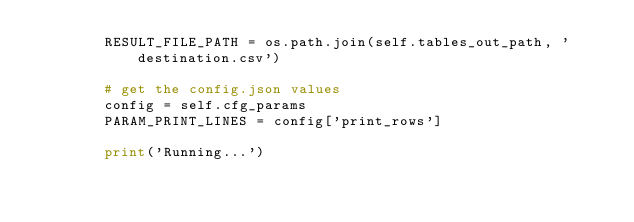<code> <loc_0><loc_0><loc_500><loc_500><_Python_>        RESULT_FILE_PATH = os.path.join(self.tables_out_path, 'destination.csv')

        # get the config.json values
        config = self.cfg_params
        PARAM_PRINT_LINES = config['print_rows']

        print('Running...')</code> 